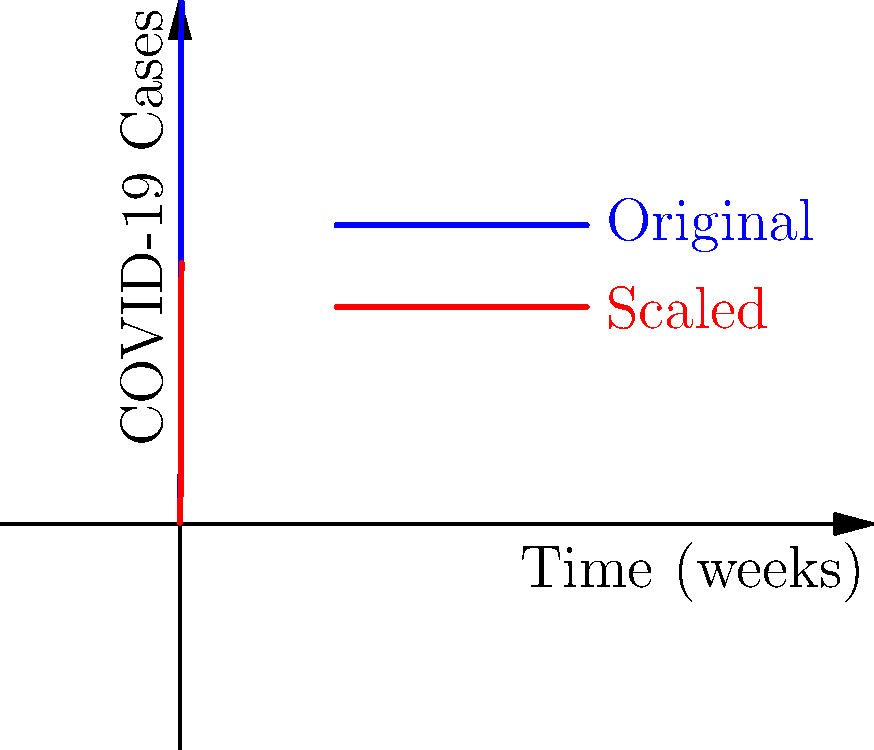A COVID-19 survivor wants to emphasize the long-term trends of the virus by scaling down a graph of cases over time. If the original graph shows the number of cases doubling every week, starting from 10 cases in week 0 and reaching 2000 cases by week 6, what scale factor should be applied to the y-axis to reduce the final number of cases to 1000 while maintaining the shape of the curve? How would this transformation be represented mathematically? To solve this problem, we need to follow these steps:

1) First, let's identify the original function. The cases are doubling every week, starting from 10. This can be represented as:

   $f(t) = 10 \cdot 2^t$, where $t$ is the number of weeks.

2) We want to scale this function so that the final value (at week 6) is 1000 instead of 2000. This means we need to multiply the original function by a scale factor $k$:

   $g(t) = k \cdot f(t) = k \cdot 10 \cdot 2^t$

3) We know that at $t=6$, $g(6)$ should equal 1000:

   $1000 = k \cdot 10 \cdot 2^6$

4) Solve for $k$:
   
   $k = \frac{1000}{10 \cdot 2^6} = \frac{1000}{640} = \frac{5}{32} = 0.15625$

5) Therefore, the scale factor is 0.15625 or 5/32.

6) The transformation can be represented mathematically as:

   $g(t) = 0.15625 \cdot f(t)$ or $g(t) = \frac{5}{32} \cdot f(t)$

This is a dilation transformation with scale factor 0.15625 (or 5/32) applied to the y-axis only.
Answer: Scale factor: 0.15625 (or 5/32). Transformation: $g(t) = 0.15625 \cdot f(t)$ 